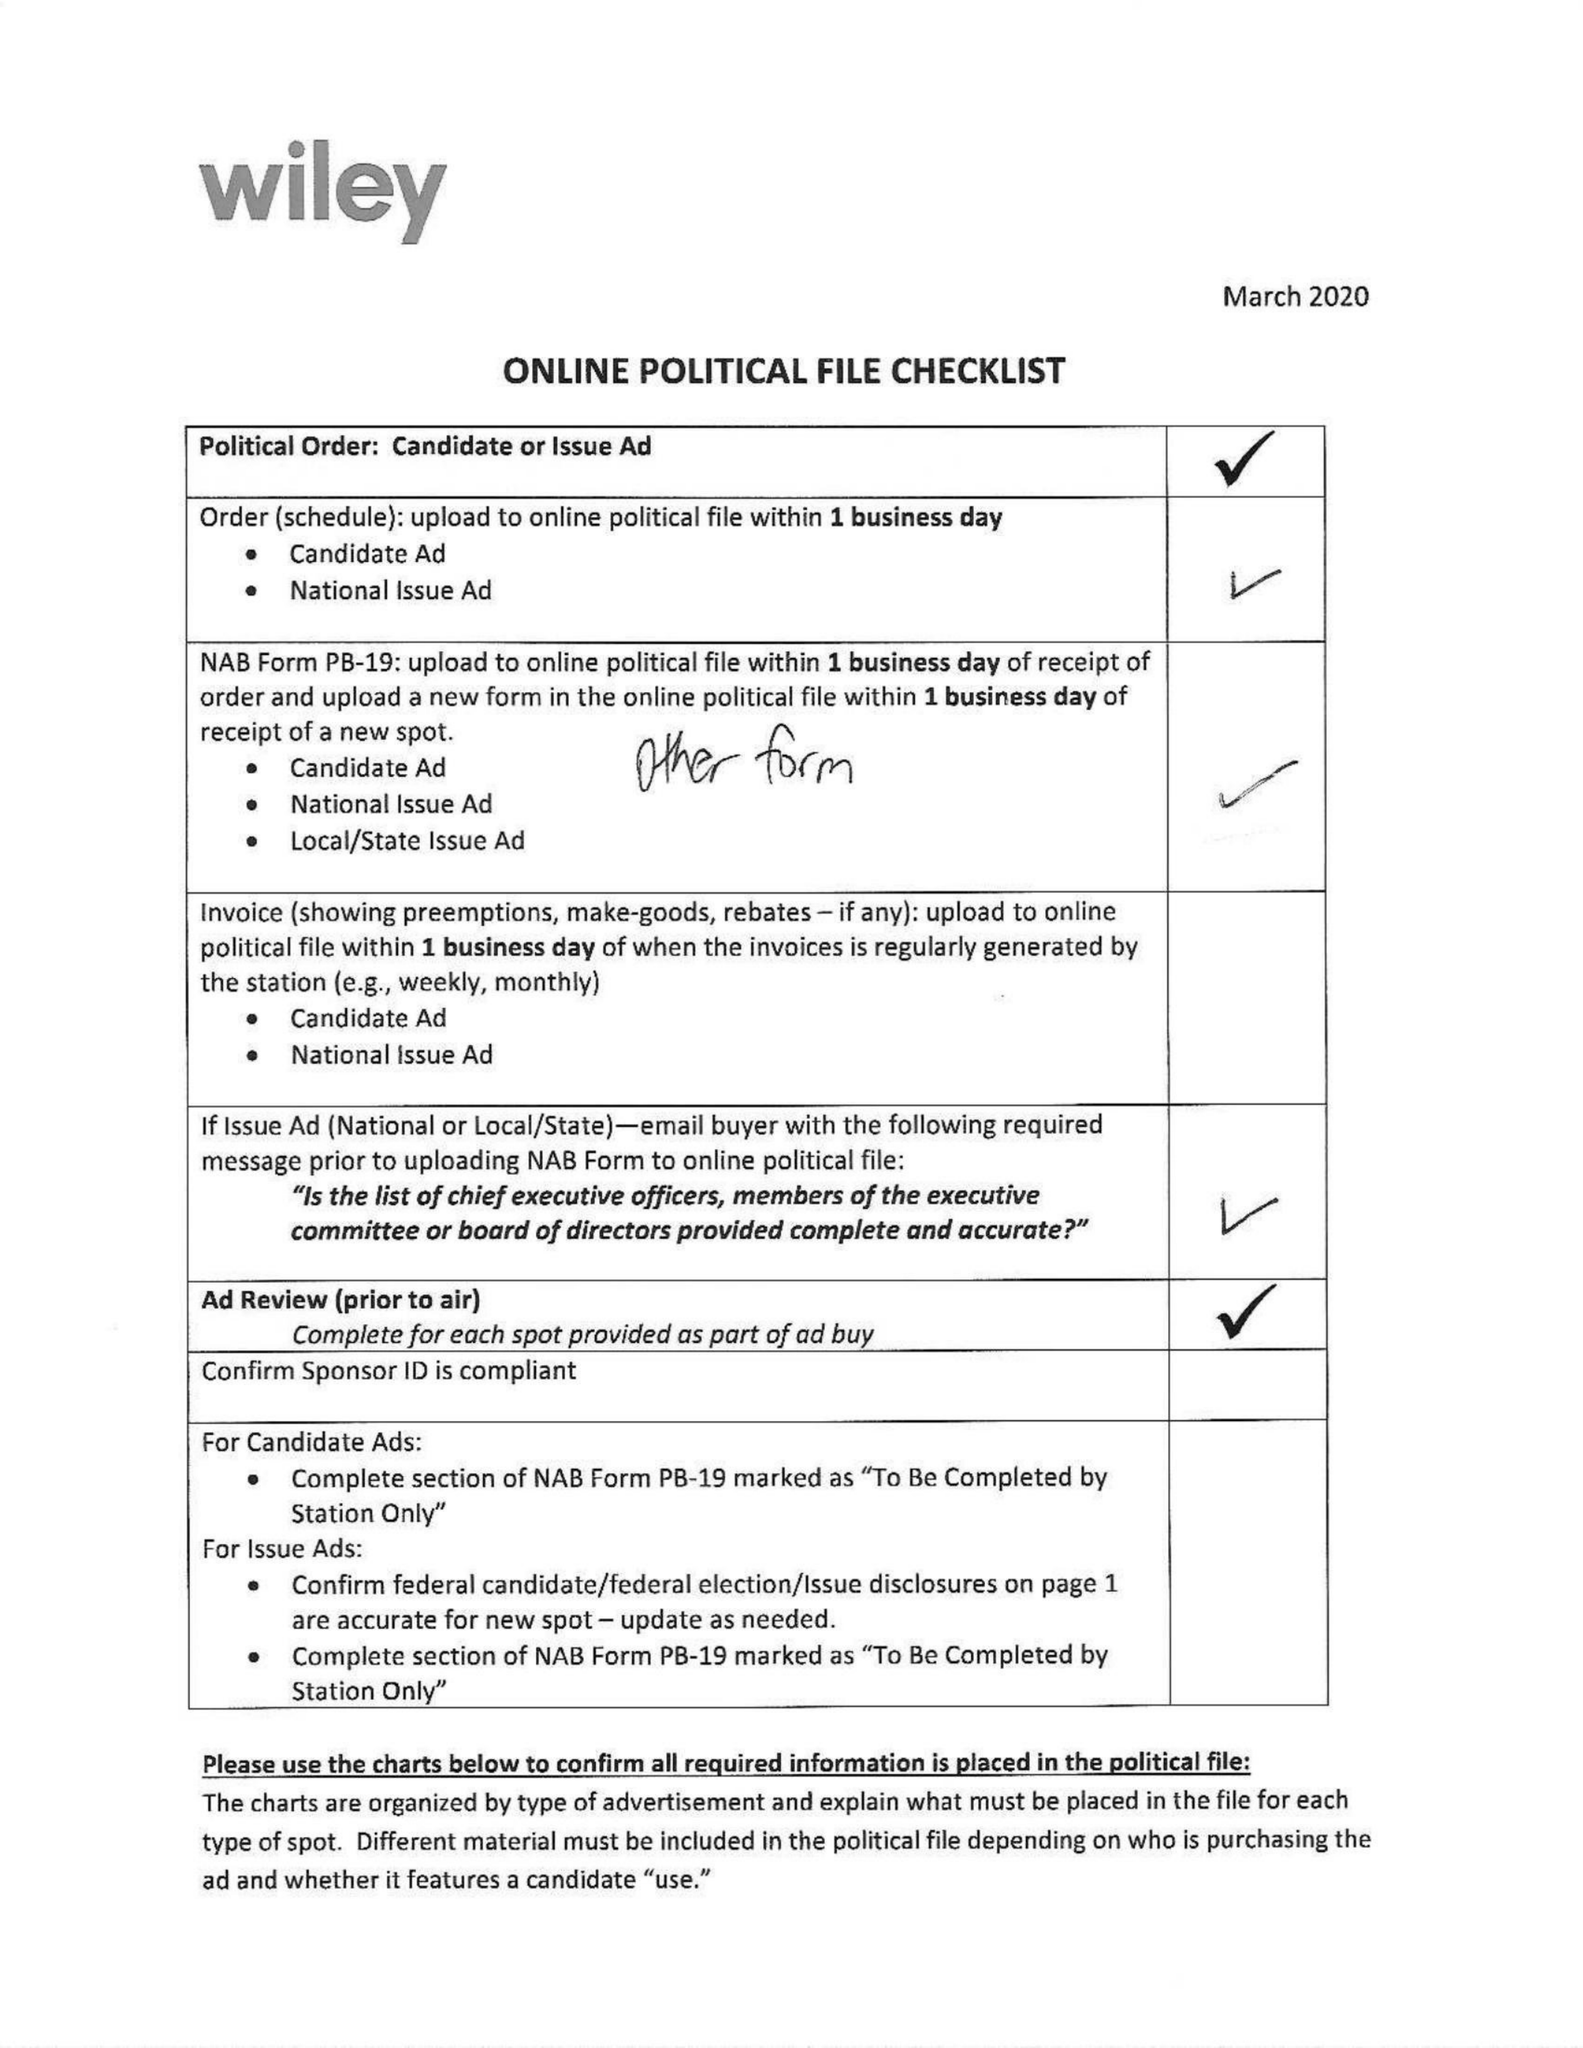What is the value for the flight_from?
Answer the question using a single word or phrase. 08/03/20 